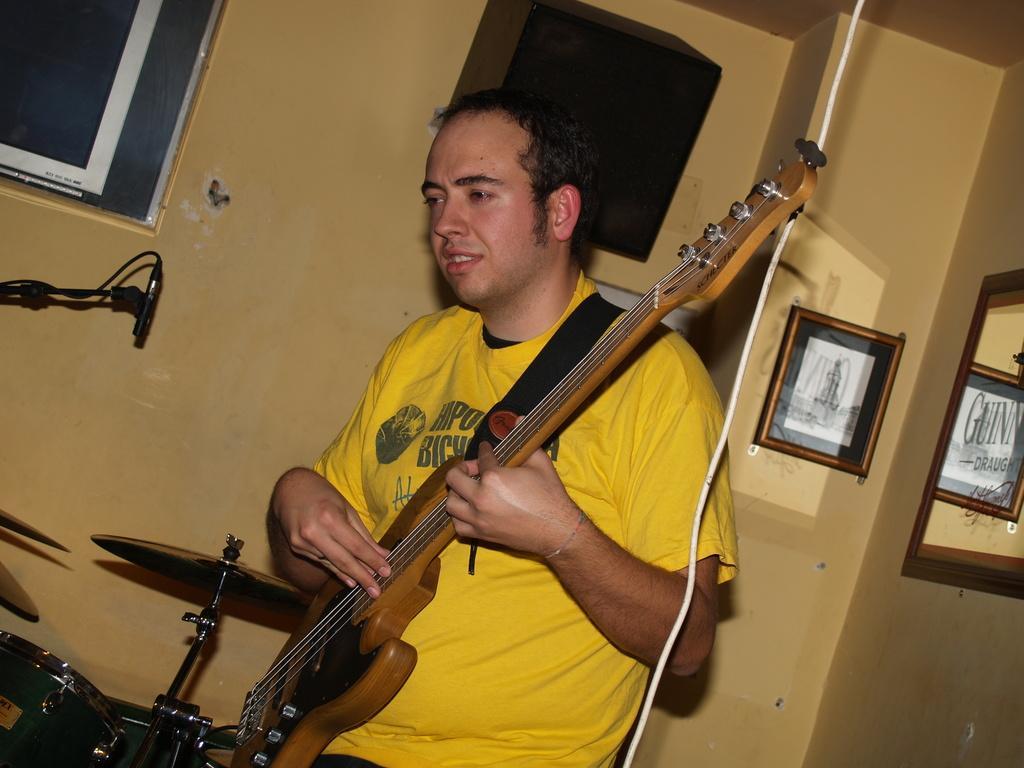Can you describe this image briefly? In this picture we can see man wore yellow color T-Shirt holding guitar in his hand and playing it and in front of him we can see drums, mic and in background we can see wall, frames. 